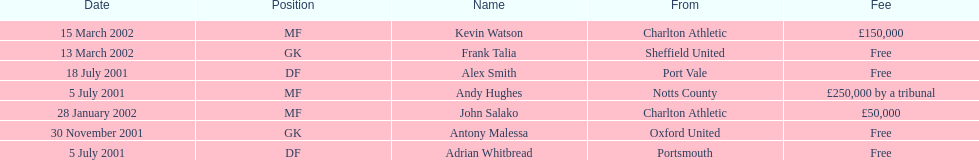Andy huges and adrian whitbread both tranfered on which date? 5 July 2001. 